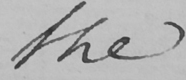What does this handwritten line say? the 